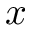Convert formula to latex. <formula><loc_0><loc_0><loc_500><loc_500>x</formula> 